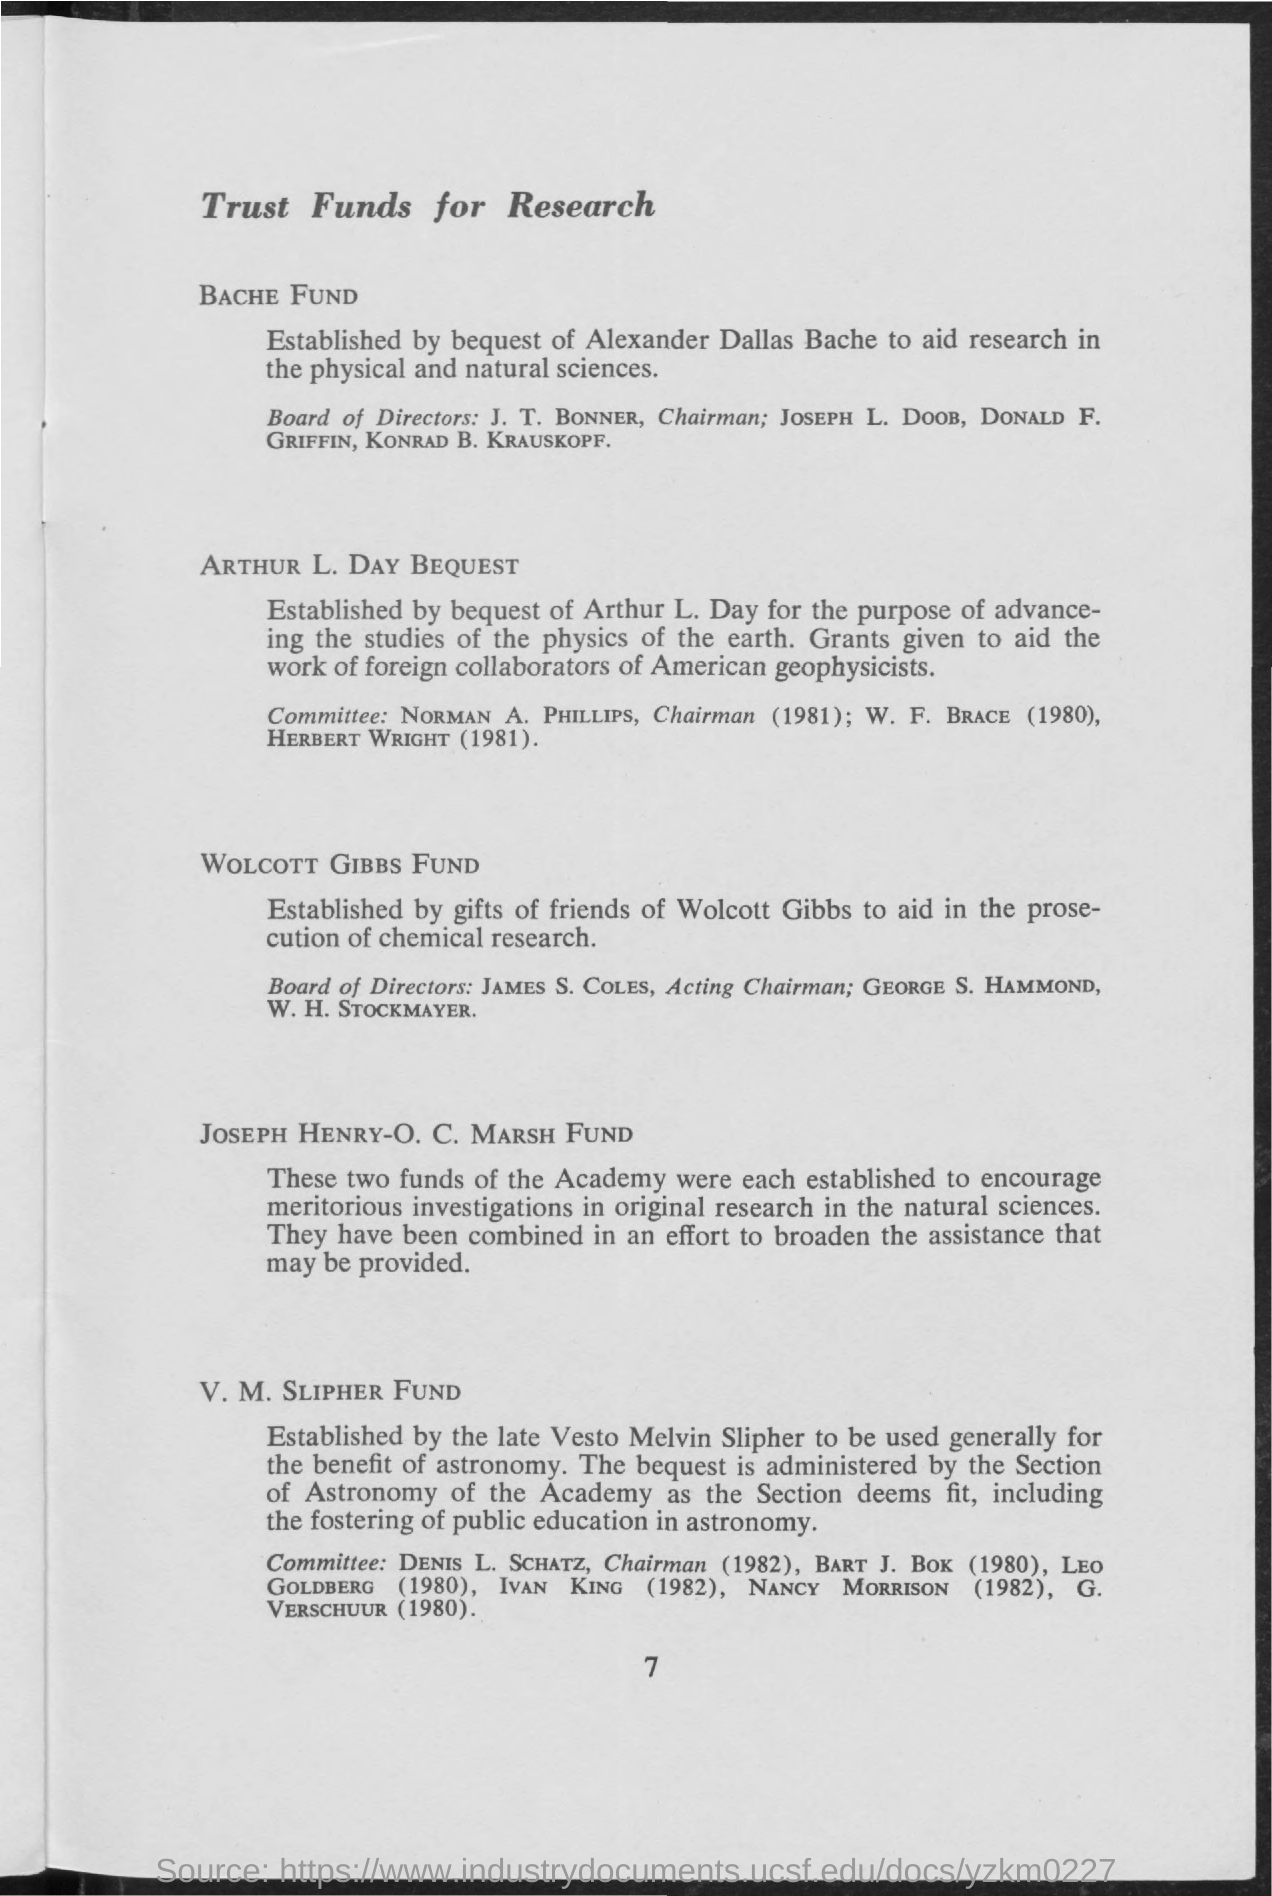What is page number?
Offer a very short reply. 7. 